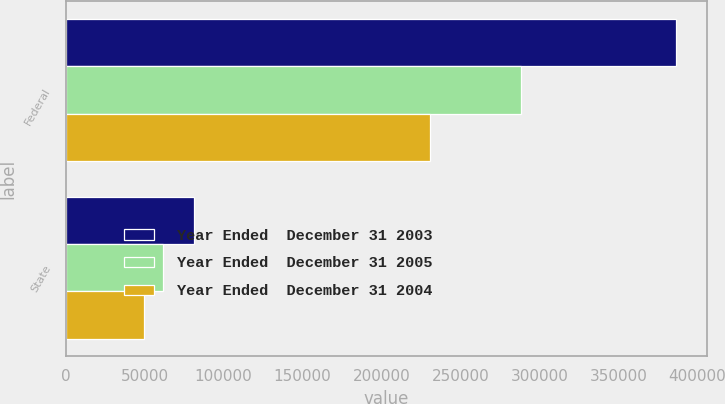<chart> <loc_0><loc_0><loc_500><loc_500><stacked_bar_chart><ecel><fcel>Federal<fcel>State<nl><fcel>Year Ended  December 31 2003<fcel>386712<fcel>81288<nl><fcel>Year Ended  December 31 2005<fcel>288069<fcel>61503<nl><fcel>Year Ended  December 31 2004<fcel>230477<fcel>49333<nl></chart> 